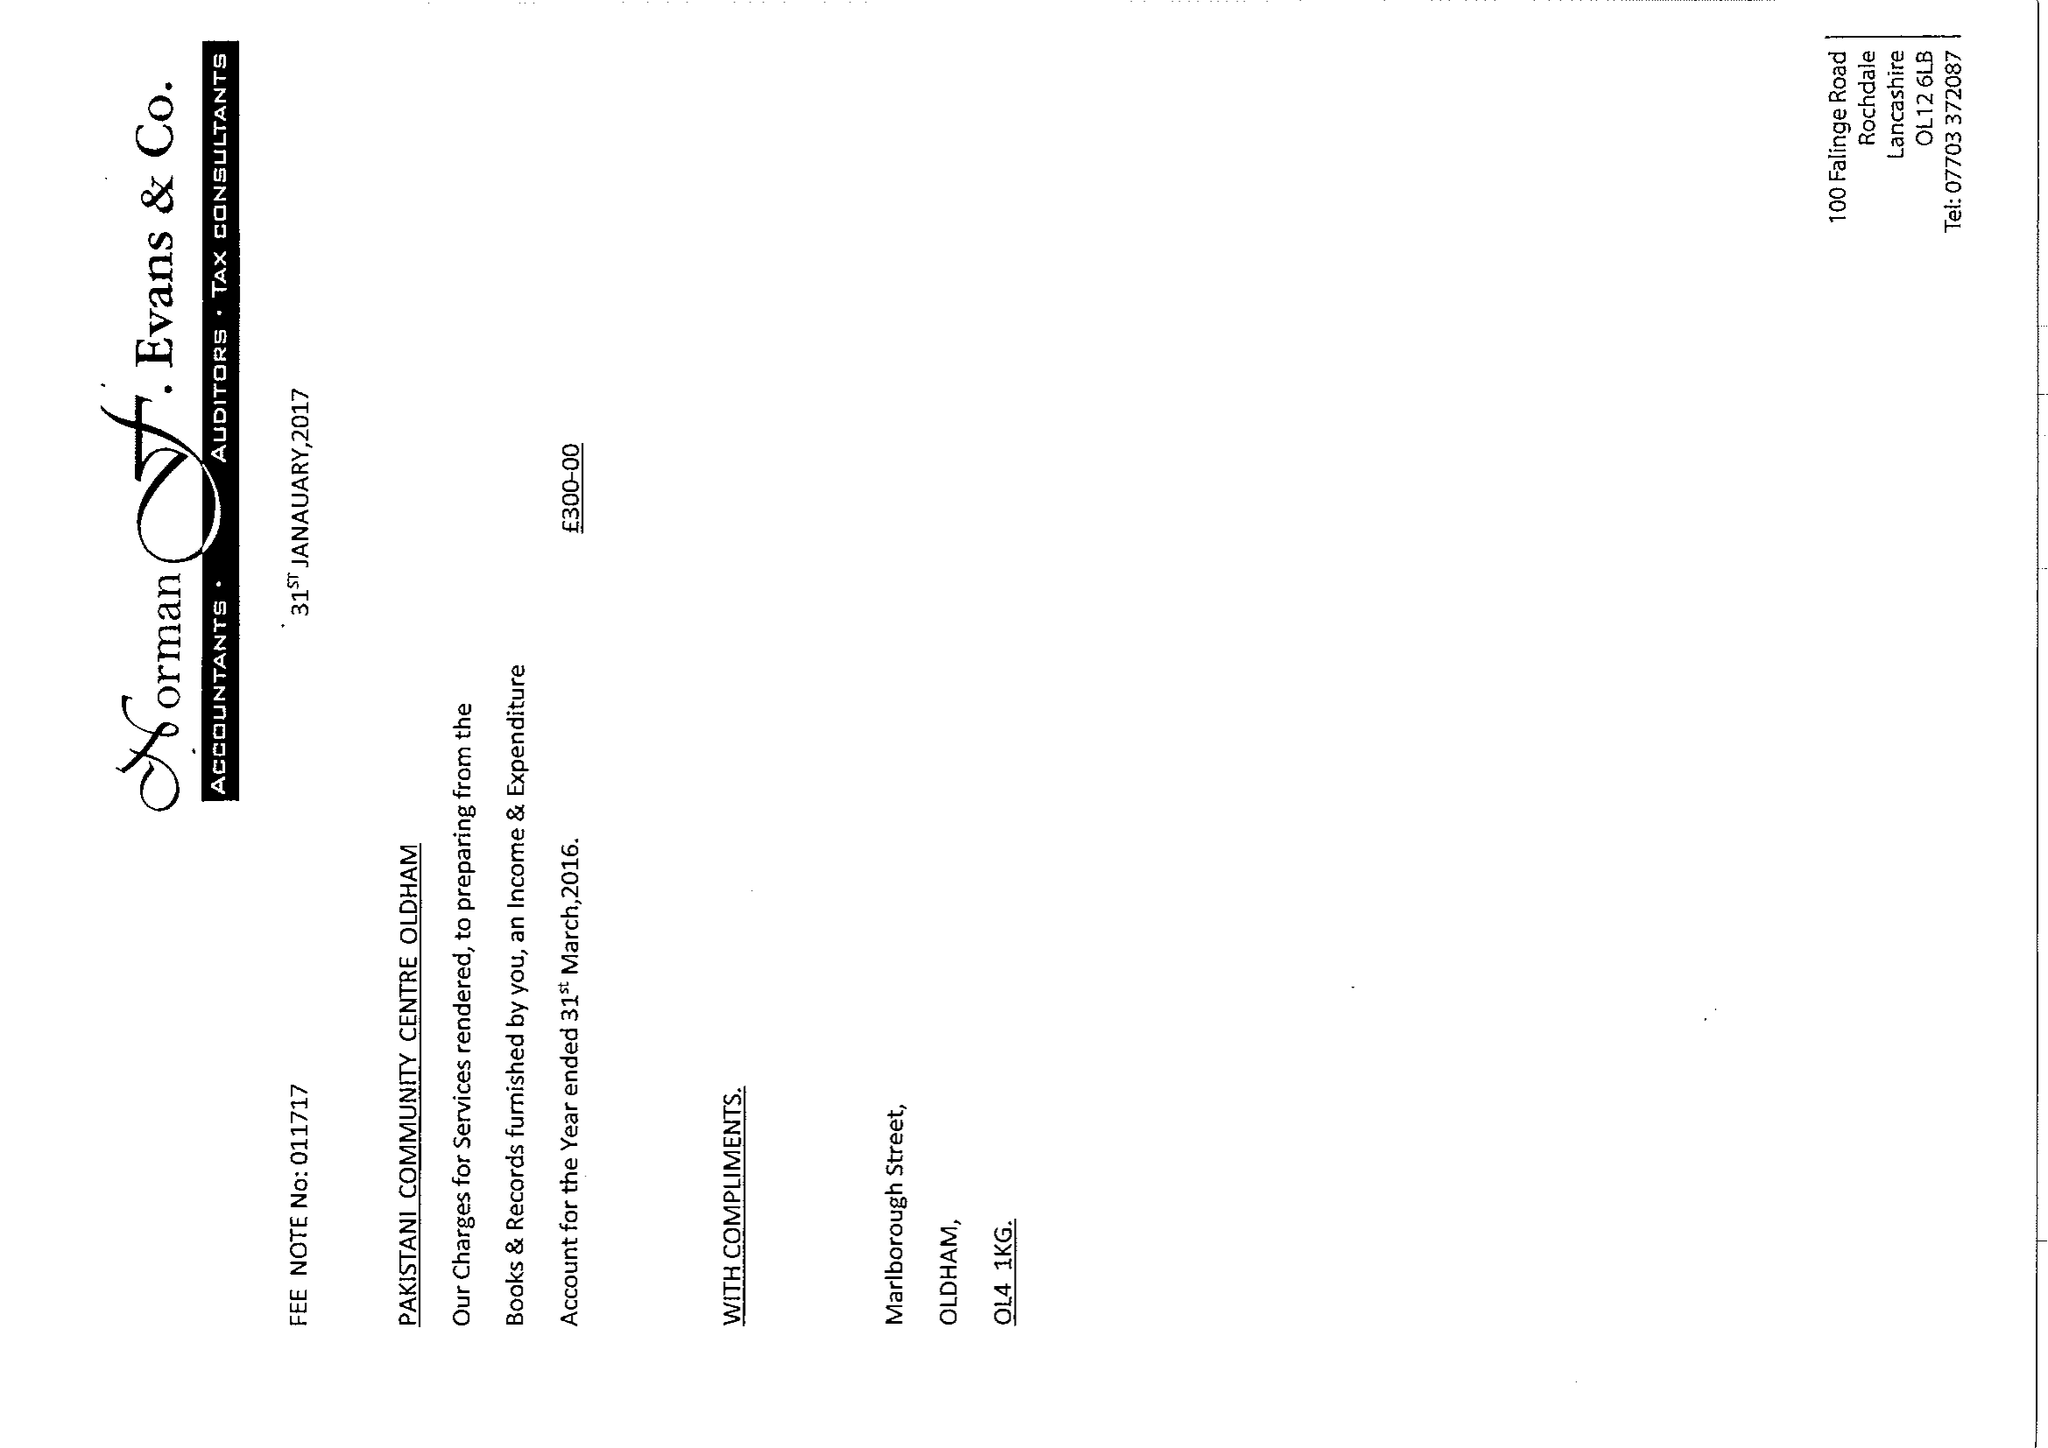What is the value for the address__street_line?
Answer the question using a single word or phrase. MARLBOROUGH STREET 